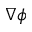<formula> <loc_0><loc_0><loc_500><loc_500>\nabla \phi</formula> 